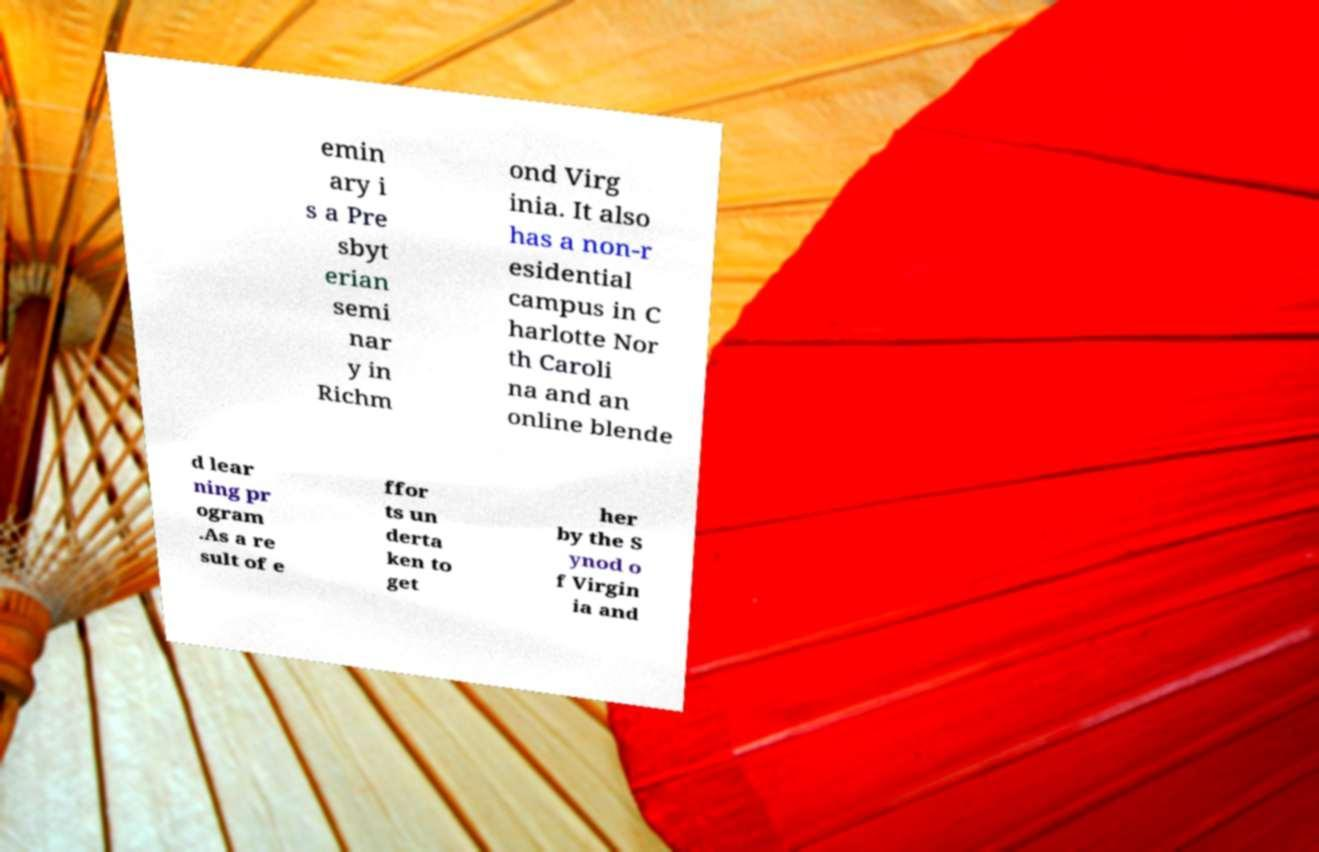Can you accurately transcribe the text from the provided image for me? emin ary i s a Pre sbyt erian semi nar y in Richm ond Virg inia. It also has a non-r esidential campus in C harlotte Nor th Caroli na and an online blende d lear ning pr ogram .As a re sult of e ffor ts un derta ken to get her by the S ynod o f Virgin ia and 